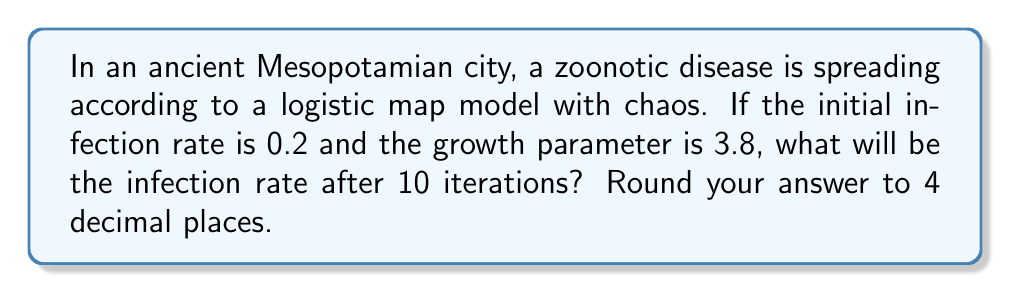Provide a solution to this math problem. To solve this problem, we'll use the logistic map equation and iterate it 10 times:

1) The logistic map equation is given by:
   $$x_{n+1} = rx_n(1-x_n)$$
   where $r$ is the growth parameter and $x_n$ is the infection rate at iteration $n$.

2) Given:
   Initial infection rate $x_0 = 0.2$
   Growth parameter $r = 3.8$

3) Let's calculate the first few iterations:
   
   $x_1 = 3.8 * 0.2 * (1-0.2) = 0.608$
   
   $x_2 = 3.8 * 0.608 * (1-0.608) = 0.9060096$
   
   $x_3 = 3.8 * 0.9060096 * (1-0.9060096) = 0.3246301$

4) We continue this process for 7 more iterations:
   
   $x_4 = 0.8334953$
   $x_5 = 0.5278861$
   $x_6 = 0.9479321$
   $x_7 = 0.1877742$
   $x_8 = 0.5799697$
   $x_9 = 0.9259424$
   $x_{10} = 0.2610256$

5) The infection rate after 10 iterations is 0.2610256.

6) Rounding to 4 decimal places: 0.2610

This chaotic behavior demonstrates how unpredictable zoonotic disease spread could be in ancient civilizations, making it a challenging subject for anthrozoological studies.
Answer: 0.2610 